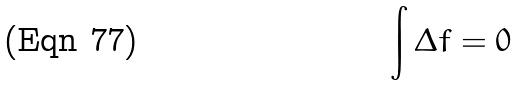<formula> <loc_0><loc_0><loc_500><loc_500>\int \Delta f = 0</formula> 